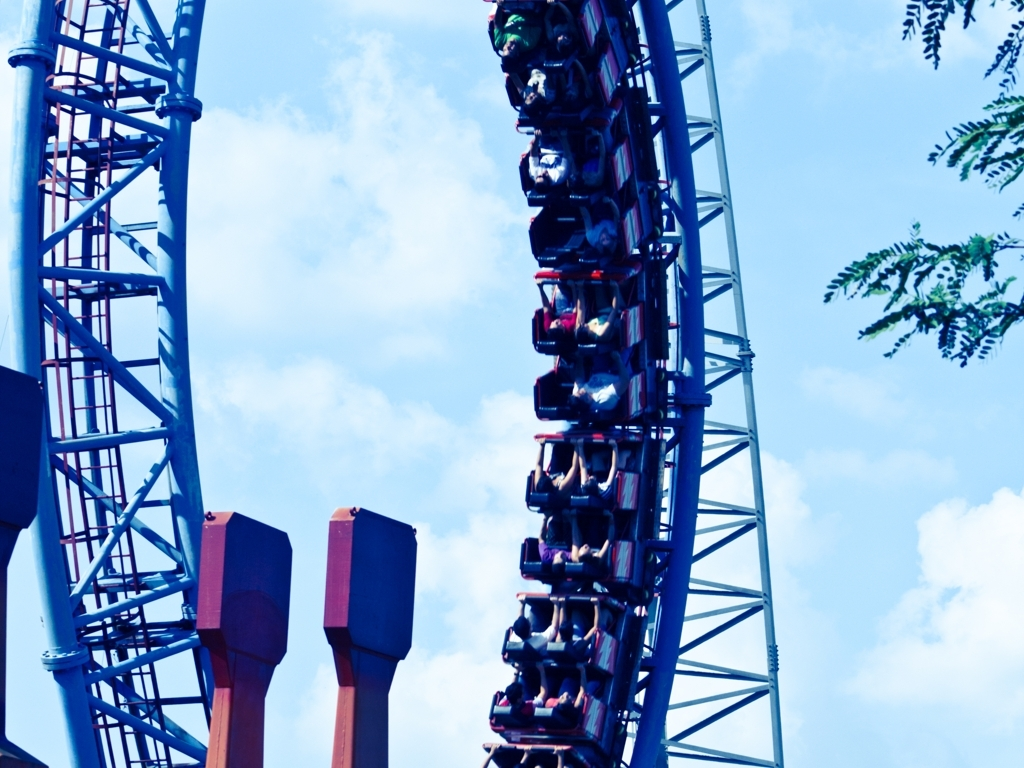What kind of roller coaster is shown in this image? The roller coaster in the image is an inverted roller coaster, which is characterized by riders sitting in trains that hang beneath the track, with their legs freely dangling. How do you know it's an inverted roller coaster? You can identify an inverted roller coaster by the design of its carriages, with the tracks above the heads of the passengers, and by noting how the riders' legs hang freely below them, creating a sensation of flying. 